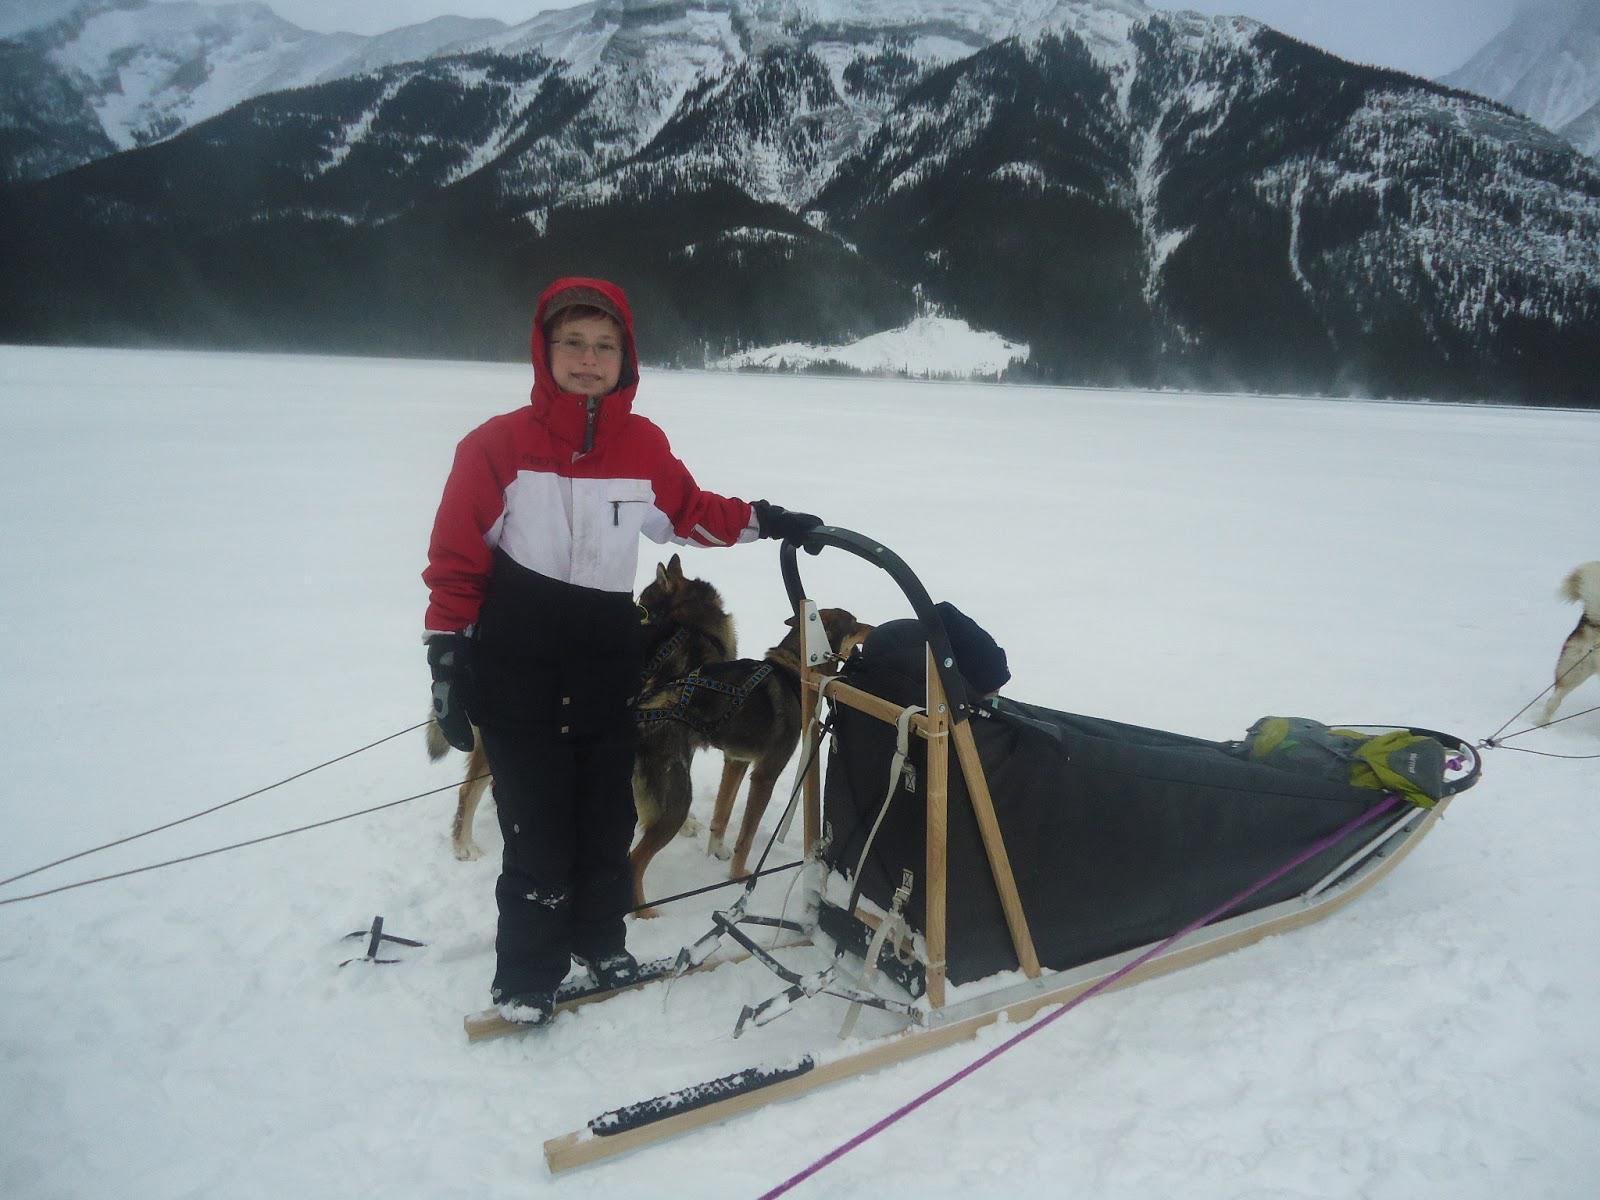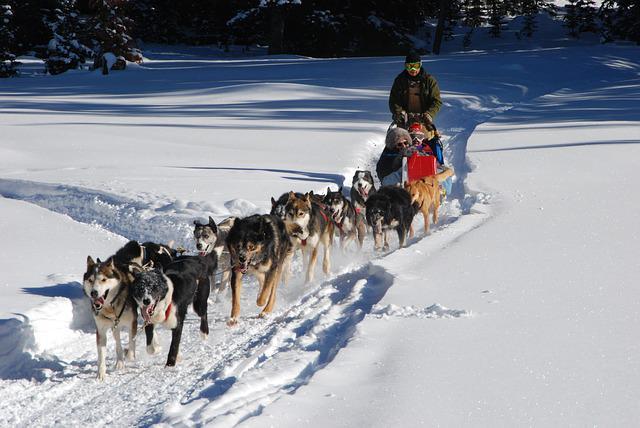The first image is the image on the left, the second image is the image on the right. Examine the images to the left and right. Is the description "There are trees in the image on the left." accurate? Answer yes or no. No. The first image is the image on the left, the second image is the image on the right. Examine the images to the left and right. Is the description "A person in a red and black jacket is in the foreground of one image." accurate? Answer yes or no. Yes. The first image is the image on the left, the second image is the image on the right. Given the left and right images, does the statement "An image shows at least one sled but fewer than 3 dogs." hold true? Answer yes or no. Yes. The first image is the image on the left, the second image is the image on the right. Analyze the images presented: Is the assertion "Three separate teams of sled dogs are harnessed." valid? Answer yes or no. No. The first image is the image on the left, the second image is the image on the right. For the images shown, is this caption "No mountains are visible behind the sleds in the right image." true? Answer yes or no. Yes. 